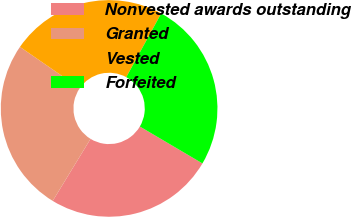Convert chart to OTSL. <chart><loc_0><loc_0><loc_500><loc_500><pie_chart><fcel>Nonvested awards outstanding<fcel>Granted<fcel>Vested<fcel>Forfeited<nl><fcel>25.24%<fcel>25.9%<fcel>23.37%<fcel>25.49%<nl></chart> 